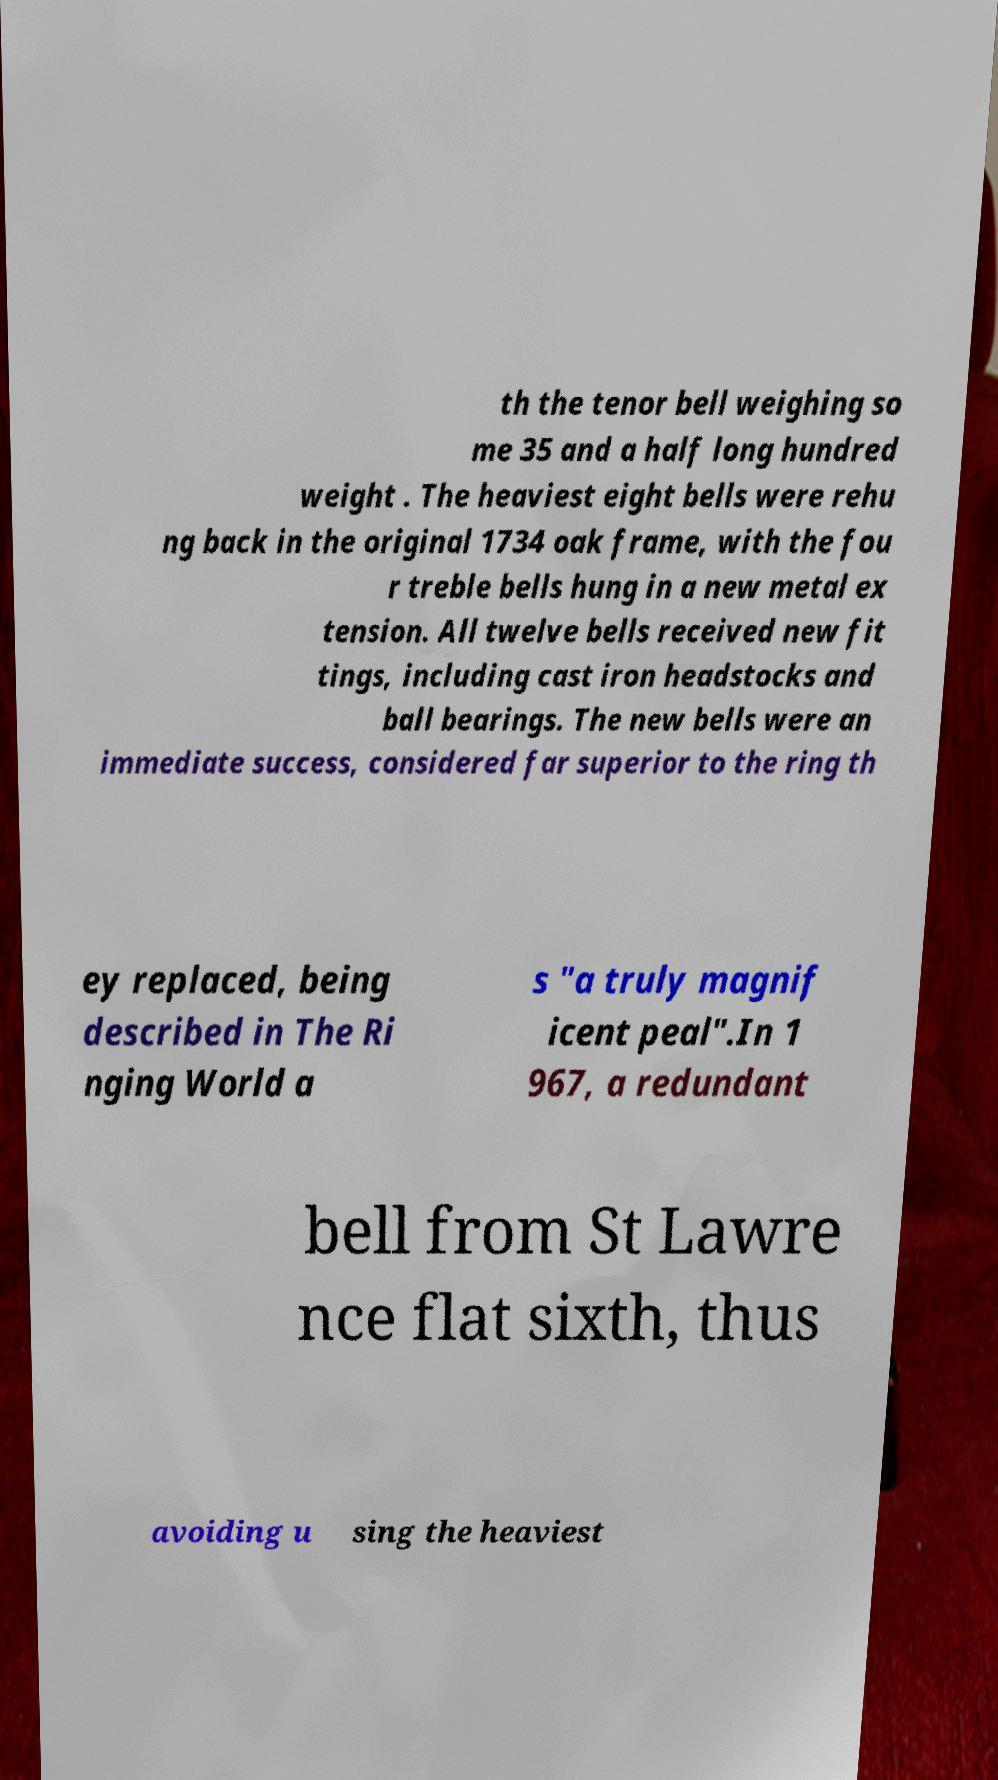Please read and relay the text visible in this image. What does it say? th the tenor bell weighing so me 35 and a half long hundred weight . The heaviest eight bells were rehu ng back in the original 1734 oak frame, with the fou r treble bells hung in a new metal ex tension. All twelve bells received new fit tings, including cast iron headstocks and ball bearings. The new bells were an immediate success, considered far superior to the ring th ey replaced, being described in The Ri nging World a s "a truly magnif icent peal".In 1 967, a redundant bell from St Lawre nce flat sixth, thus avoiding u sing the heaviest 